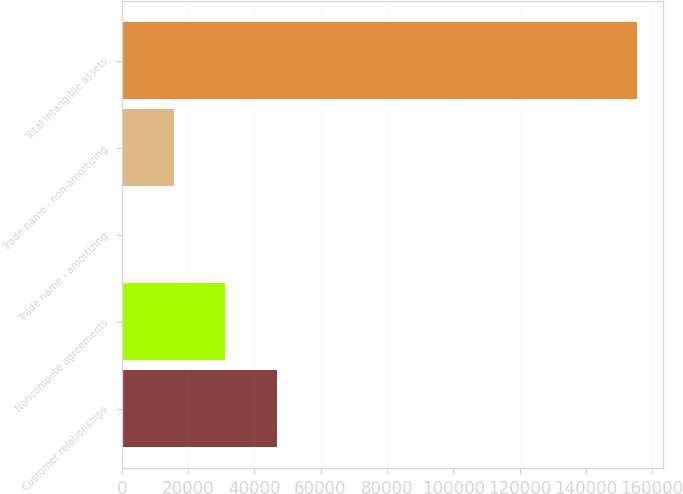Convert chart. <chart><loc_0><loc_0><loc_500><loc_500><bar_chart><fcel>Customer relationships<fcel>Noncompete agreements<fcel>Trade name - amortizing<fcel>Trade name - non-amortizing<fcel>Total intangible assets<nl><fcel>46805.8<fcel>31272.2<fcel>205<fcel>15738.6<fcel>155541<nl></chart> 